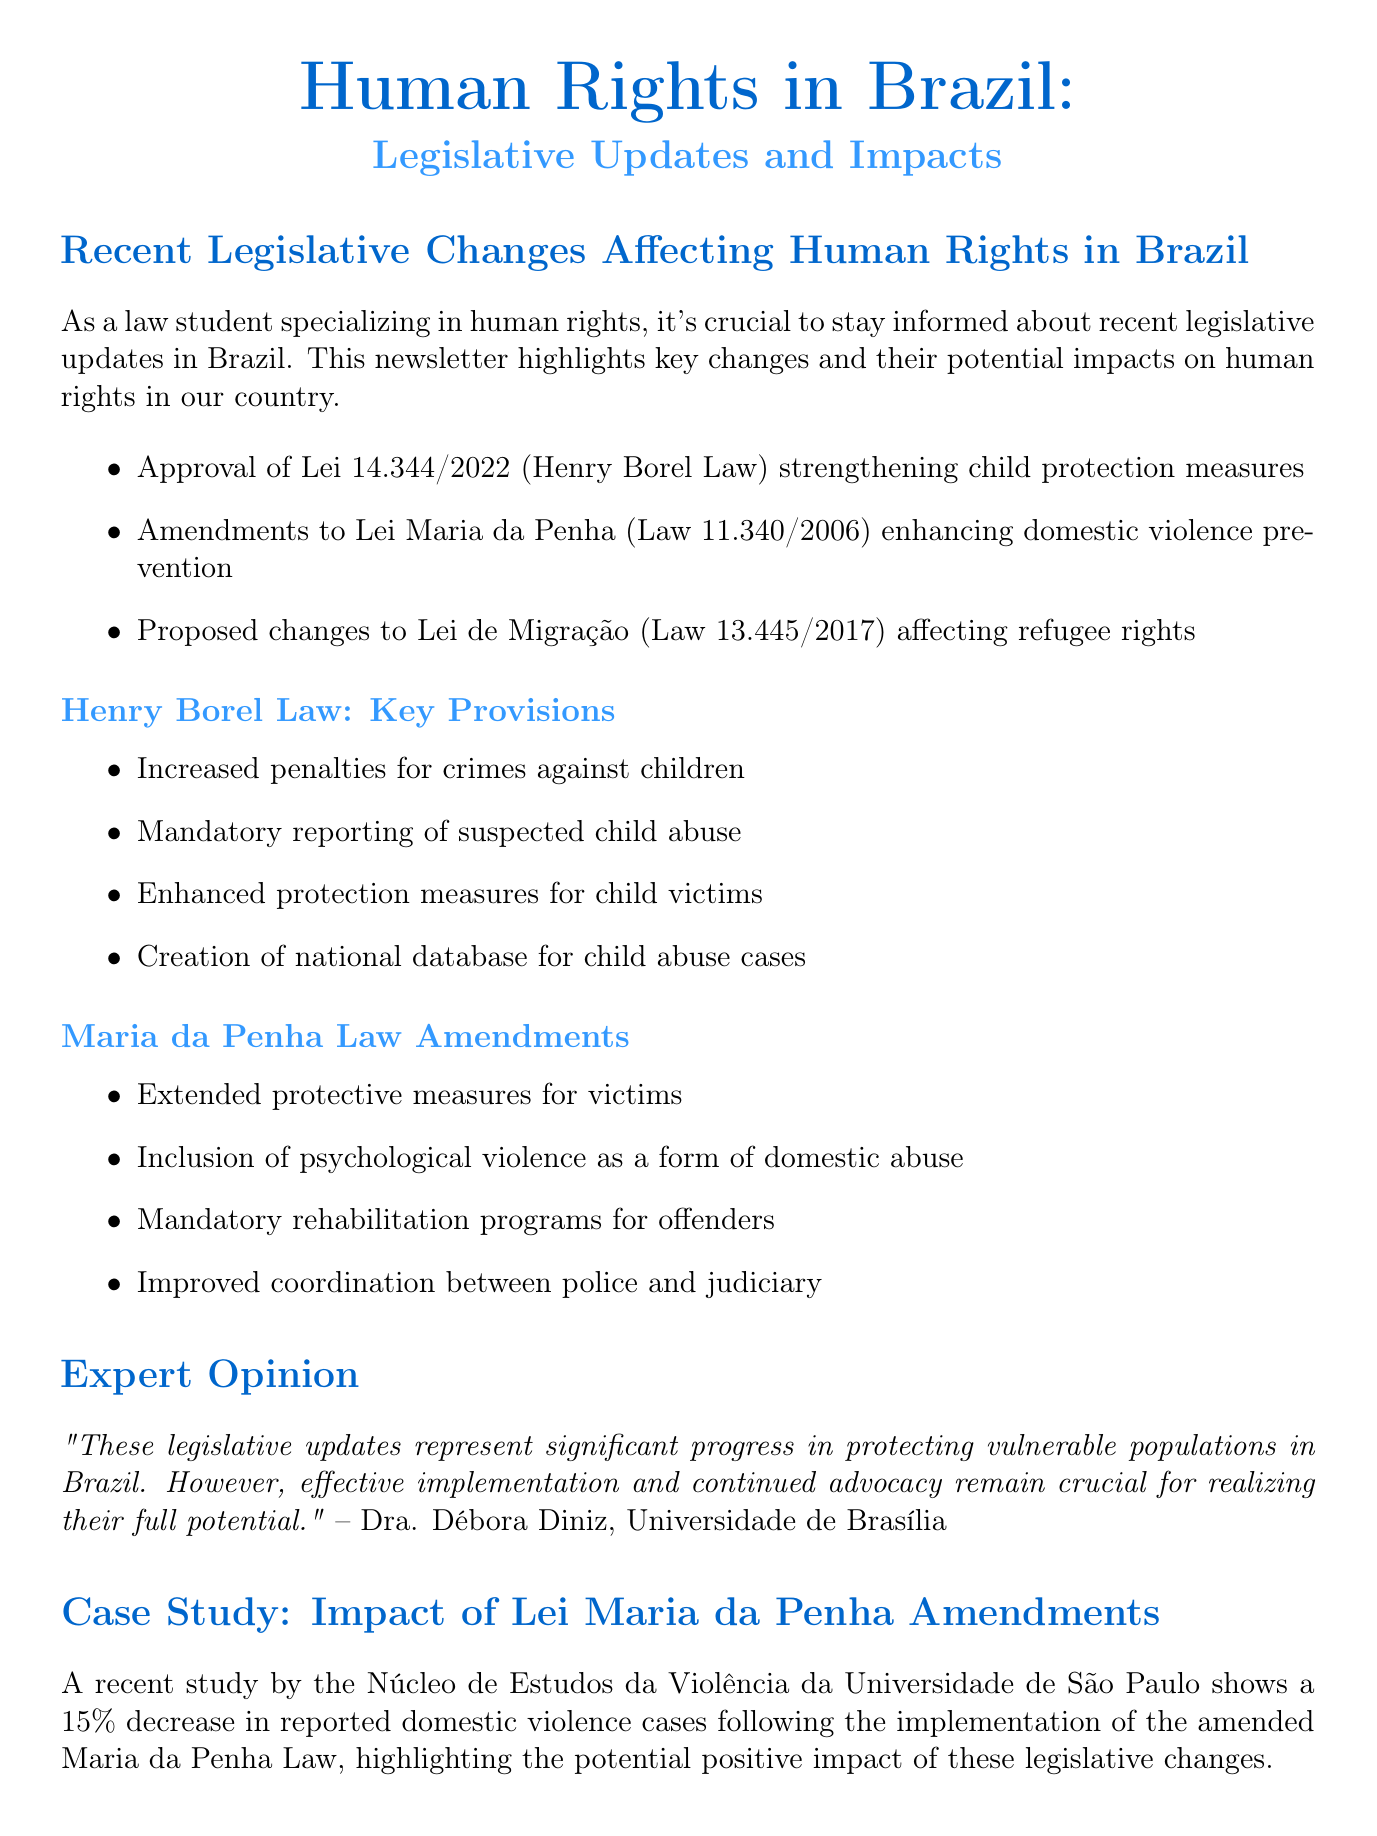what is the title of the newsletter? The title of the newsletter is stated at the beginning of the document as "Human Rights in Brazil: Legislative Updates and Impacts".
Answer: Human Rights in Brazil: Legislative Updates and Impacts what law enhances domestic violence prevention? The law that enhances domestic violence prevention is mentioned in the key points section of the newsletter.
Answer: Lei Maria da Penha who authored the expert opinion section? The expert opinion section is attributed to a specific individual mentioned in the document.
Answer: Dra. Débora Diniz what percentage decrease in reported domestic violence cases was noted in the study? The document provides statistical information regarding the impact of legislative changes on domestic violence cases.
Answer: 15% what is one of the key provisions of the Henry Borel Law? The newsletter lists several key provisions of the Henry Borel Law in the infographic.
Answer: Increased penalties for crimes against children when is the "Seminário Nacional de Direitos Humanos" scheduled? The document specifies the date for the upcoming event related to human rights.
Answer: August 15-17, 2023 which law includes psychological violence as a form of domestic abuse? The newsletter describes the law that has been amended to include psychological abuse in the context of domestic violence.
Answer: Lei Maria da Penha where can the full text of Lei 14.344/2022 be found? The resource links section provides a link to the full text of the Henry Borel Law.
Answer: http://www.planalto.gov.br/ccivil_03/_ato2019-2022/2022/lei/L14344.htm 